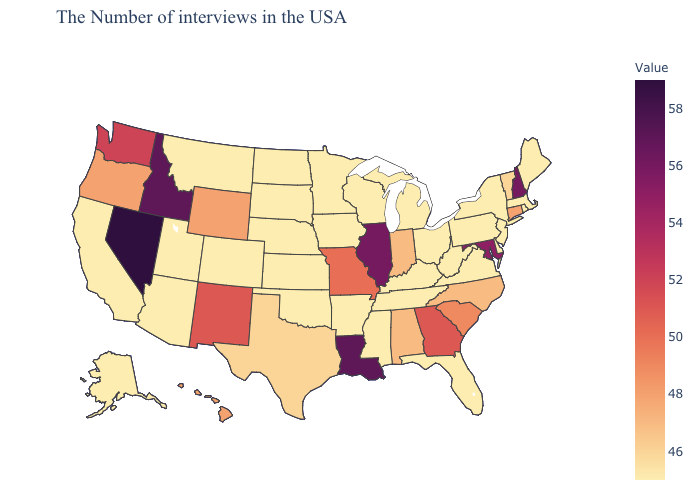Does the map have missing data?
Concise answer only. No. Among the states that border Nevada , does Idaho have the highest value?
Keep it brief. Yes. Does Connecticut have the lowest value in the USA?
Concise answer only. No. Which states have the lowest value in the USA?
Short answer required. Maine, Massachusetts, Rhode Island, New York, New Jersey, Delaware, Pennsylvania, Virginia, West Virginia, Ohio, Florida, Michigan, Kentucky, Tennessee, Wisconsin, Mississippi, Arkansas, Minnesota, Iowa, Kansas, Nebraska, Oklahoma, South Dakota, North Dakota, Colorado, Utah, Montana, Arizona, California, Alaska. 